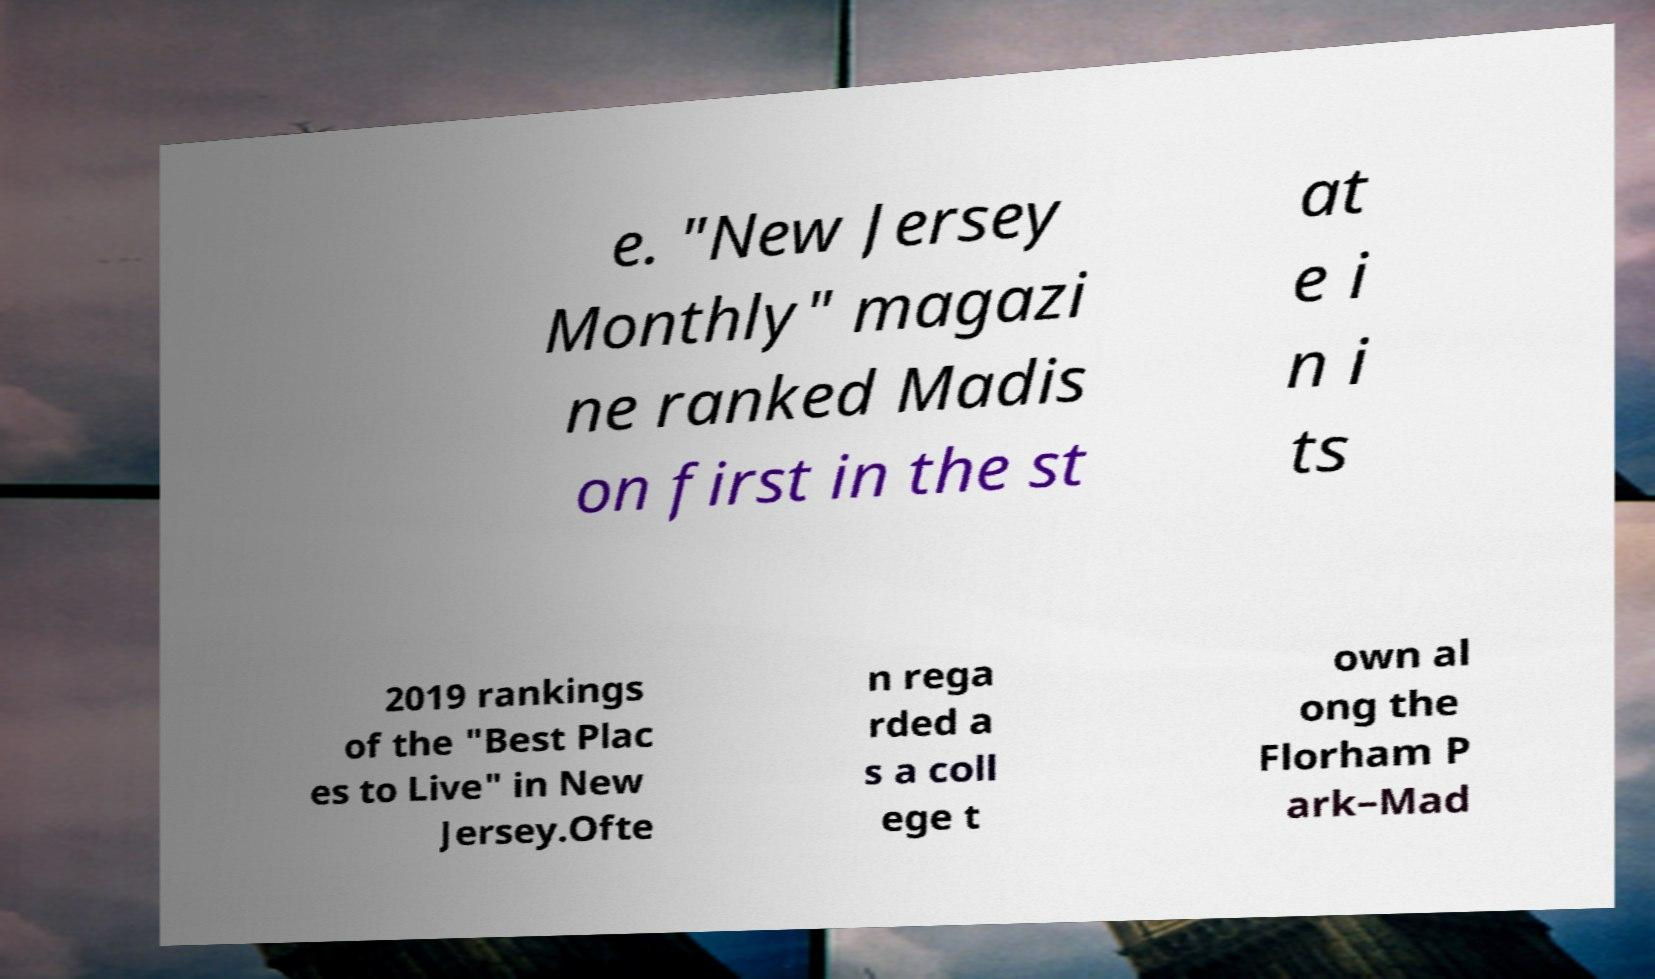Please read and relay the text visible in this image. What does it say? e. "New Jersey Monthly" magazi ne ranked Madis on first in the st at e i n i ts 2019 rankings of the "Best Plac es to Live" in New Jersey.Ofte n rega rded a s a coll ege t own al ong the Florham P ark–Mad 